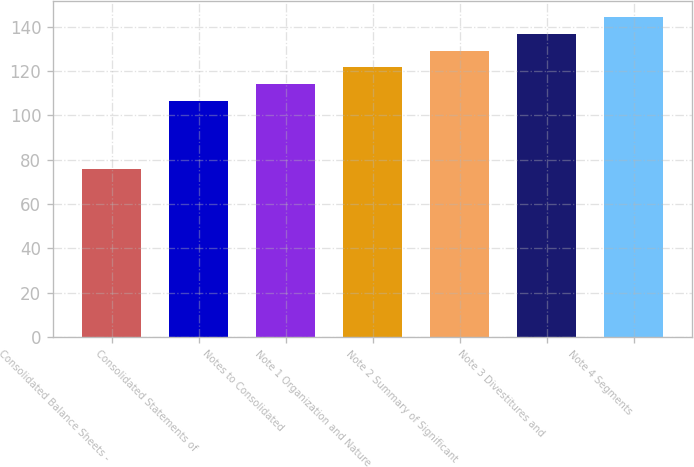Convert chart. <chart><loc_0><loc_0><loc_500><loc_500><bar_chart><fcel>Consolidated Balance Sheets -<fcel>Consolidated Statements of<fcel>Notes to Consolidated<fcel>Note 1 Organization and Nature<fcel>Note 2 Summary of Significant<fcel>Note 3 Divestitures and<fcel>Note 4 Segments<nl><fcel>76<fcel>106.4<fcel>114<fcel>121.6<fcel>129.2<fcel>136.8<fcel>144.4<nl></chart> 